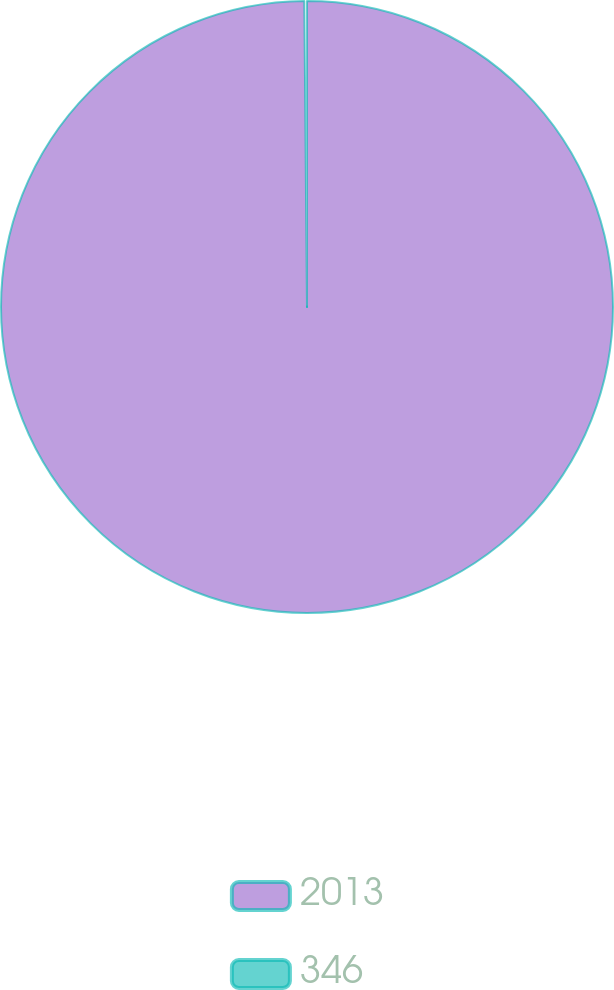<chart> <loc_0><loc_0><loc_500><loc_500><pie_chart><fcel>2013<fcel>346<nl><fcel>99.86%<fcel>0.14%<nl></chart> 